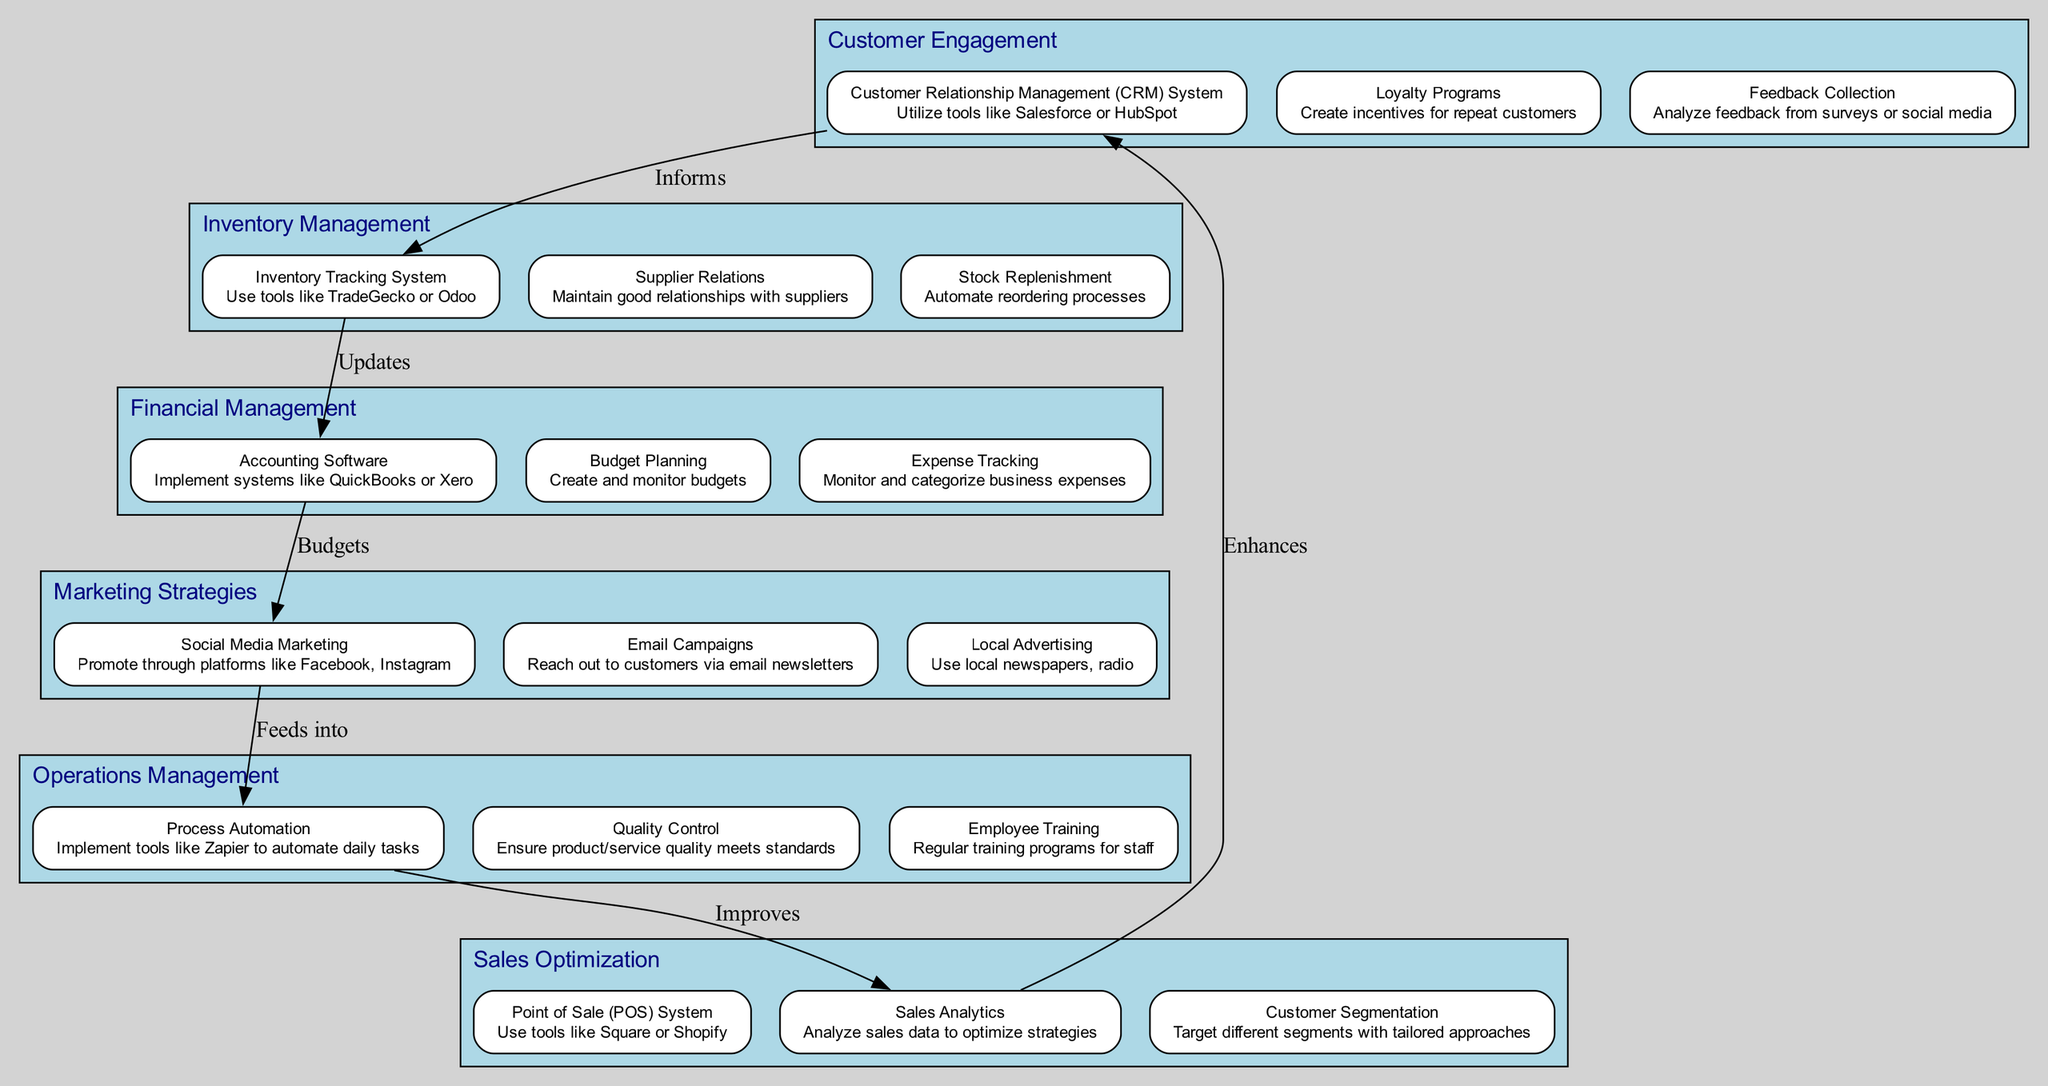What's the name of the first block in the diagram? The first block in the diagram is labeled "Customer Engagement."
Answer: Customer Engagement How many blocks are there in the diagram? There are six blocks represented in the diagram.
Answer: Six What tool is suggested for "Inventory Tracking System"? The diagram suggests using tools like TradeGecko or Odoo for the "Inventory Tracking System."
Answer: TradeGecko or Odoo What does "Sales Analytics" improve? According to the diagram, "Sales Analytics" improves "Process Automation."
Answer: Process Automation Which block feeds into "Financial Management"? The "Social Media Marketing" block feeds into "Financial Management" in the diagram, as it is connected to the "Accounting Software."
Answer: Social Media Marketing What is the relationship between "Customer Relationship Management (CRM) System" and "Inventory Tracking System"? The relationship indicated is that the "Customer Relationship Management (CRM) System)" informs the "Inventory Tracking System."
Answer: Informs Which element from the "Operations Management" block is focused on employee development? The "Employee Training" element from the "Operations Management" block focuses on employee development.
Answer: Employee Training What type of automation is mentioned in the "Operations Management" block? The type of automation mentioned in the block is "Process Automation."
Answer: Process Automation How do "Loyalty Programs" relate to maintaining customer relationships? "Loyalty Programs" are part of the "Customer Engagement" processes aimed at retaining customers through incentives.
Answer: Retain customers What element connects the "Sales Optimization" block back to the "Customer Engagement"? The element "Customer Segmentation" connects the "Sales Optimization" block back to the "Customer Engagement" by targeting different segments.
Answer: Customer Segmentation 